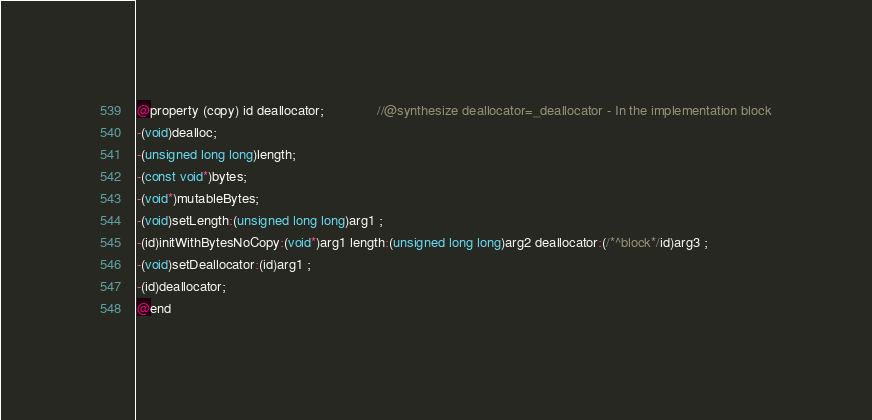Convert code to text. <code><loc_0><loc_0><loc_500><loc_500><_C_>
@property (copy) id deallocator;              //@synthesize deallocator=_deallocator - In the implementation block
-(void)dealloc;
-(unsigned long long)length;
-(const void*)bytes;
-(void*)mutableBytes;
-(void)setLength:(unsigned long long)arg1 ;
-(id)initWithBytesNoCopy:(void*)arg1 length:(unsigned long long)arg2 deallocator:(/*^block*/id)arg3 ;
-(void)setDeallocator:(id)arg1 ;
-(id)deallocator;
@end

</code> 